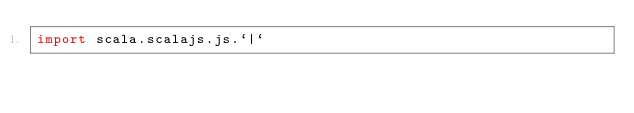<code> <loc_0><loc_0><loc_500><loc_500><_Scala_>import scala.scalajs.js.`|`</code> 